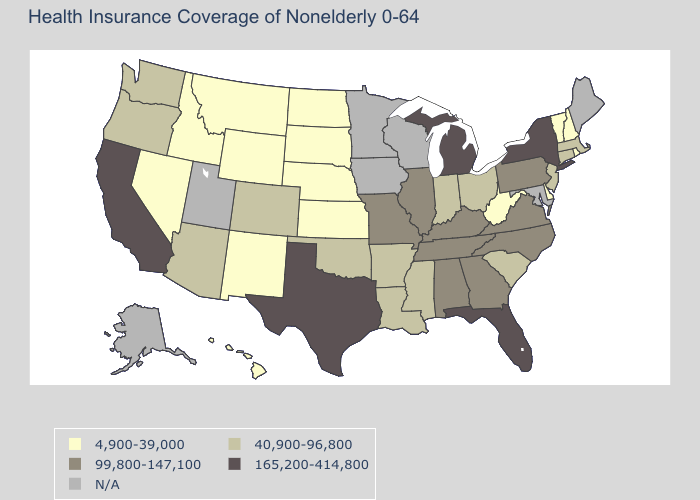What is the highest value in states that border Massachusetts?
Write a very short answer. 165,200-414,800. Which states have the lowest value in the USA?
Concise answer only. Delaware, Hawaii, Idaho, Kansas, Montana, Nebraska, Nevada, New Hampshire, New Mexico, North Dakota, Rhode Island, South Dakota, Vermont, West Virginia, Wyoming. What is the value of Nebraska?
Answer briefly. 4,900-39,000. Does New York have the highest value in the USA?
Concise answer only. Yes. Name the states that have a value in the range 99,800-147,100?
Answer briefly. Alabama, Georgia, Illinois, Kentucky, Missouri, North Carolina, Pennsylvania, Tennessee, Virginia. What is the value of Washington?
Answer briefly. 40,900-96,800. What is the highest value in states that border Montana?
Write a very short answer. 4,900-39,000. Name the states that have a value in the range 99,800-147,100?
Give a very brief answer. Alabama, Georgia, Illinois, Kentucky, Missouri, North Carolina, Pennsylvania, Tennessee, Virginia. Which states have the lowest value in the USA?
Keep it brief. Delaware, Hawaii, Idaho, Kansas, Montana, Nebraska, Nevada, New Hampshire, New Mexico, North Dakota, Rhode Island, South Dakota, Vermont, West Virginia, Wyoming. How many symbols are there in the legend?
Keep it brief. 5. Name the states that have a value in the range 4,900-39,000?
Be succinct. Delaware, Hawaii, Idaho, Kansas, Montana, Nebraska, Nevada, New Hampshire, New Mexico, North Dakota, Rhode Island, South Dakota, Vermont, West Virginia, Wyoming. Name the states that have a value in the range N/A?
Write a very short answer. Alaska, Iowa, Maine, Maryland, Minnesota, Utah, Wisconsin. 